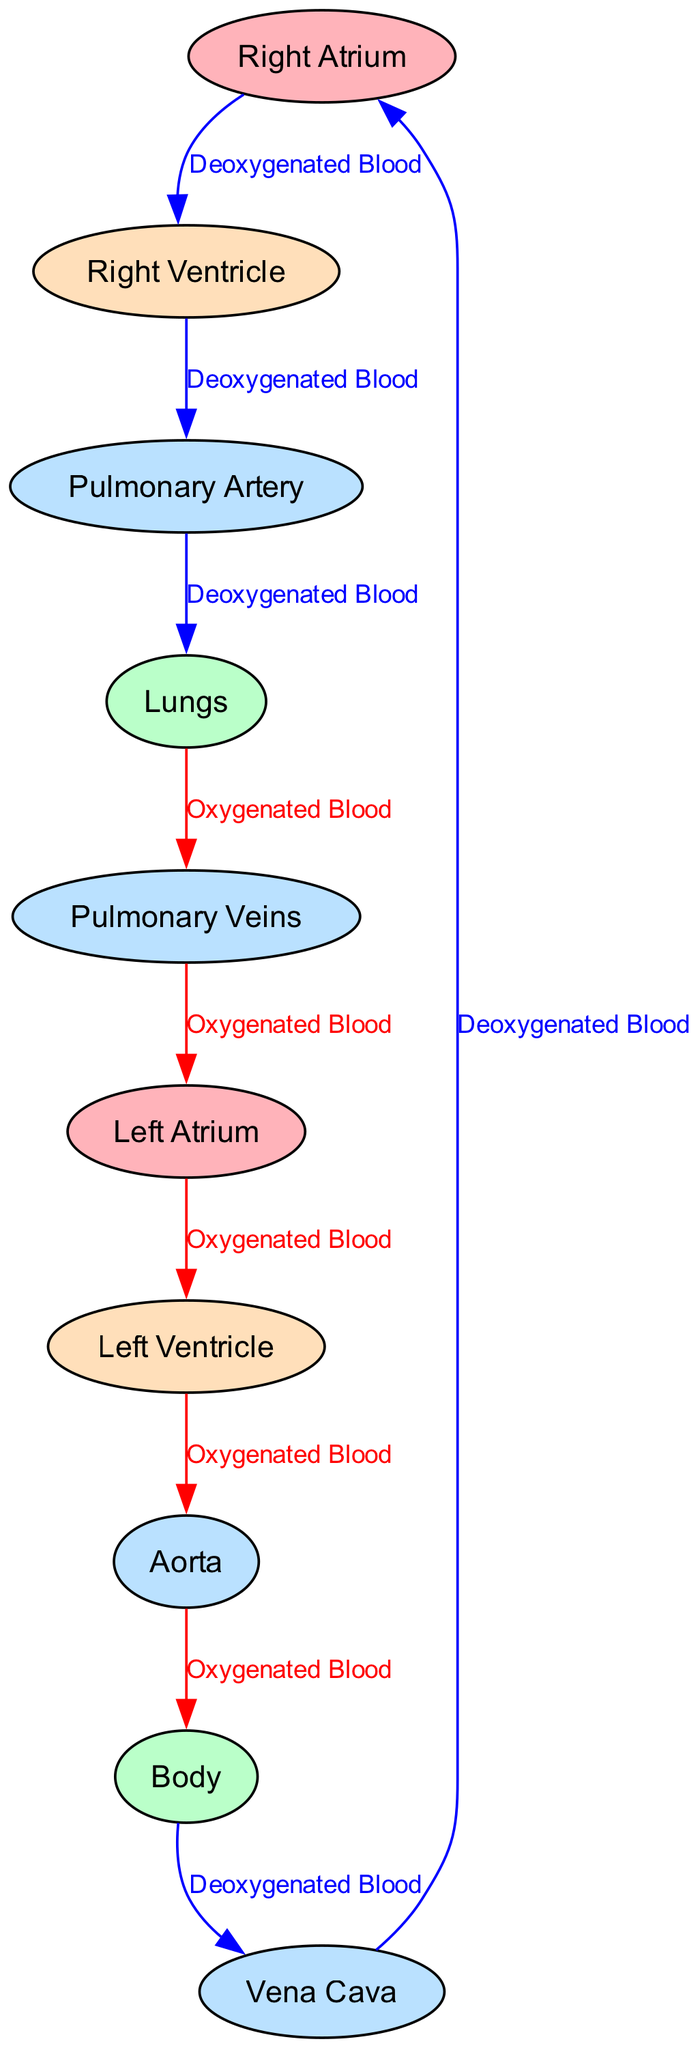What is the first chamber blood enters from the vena cava? The flow starts from the vena cava, which leads directly to the right atrium, as indicated by the directed edge in the diagram. Therefore, the first chamber is the right atrium.
Answer: Right Atrium How many major chambers are there in the heart? The diagram shows four major chambers: right atrium, right ventricle, left atrium, and left ventricle. By counting these nodes, we find there are four chambers in total.
Answer: 4 What type of blood flows from the left ventricle to the aorta? The edge labeled "Oxygenated Blood" indicates that blood leaving the left ventricle and heading to the aorta is oxygenated. Thus, the answer reflects the type of blood being transported.
Answer: Oxygenated Blood Which node receives deoxygenated blood just before reaching the lungs? Following the flow of deoxygenated blood from the right ventricle through the pulmonary artery, it leads to the lungs. Therefore, the lungs receive the deoxygenated blood just before it gets oxygenated.
Answer: Lungs What color represents the veins in this diagram? Based on the color coding explained in the diagram description, the nodes representing vessels, including veins, are colored light blue. Thus, the answer is directly related to the visual representation of veins.
Answer: Light Blue What is the last destination for oxygenated blood in this circulatory diagram? The flow path indicates that oxygenated blood travels from the aorta to the body, making the body the final destination before returning to the heart.
Answer: Body How many edges represent the flow of deoxygenated blood? By reviewing the connections in the diagram, there are five edges labeled with "Deoxygenated Blood" that represent its flow through the different nodes. Counting these will provide the answer.
Answer: 5 Which node connects the left atrium and left ventricle? The connection between the left atrium and left ventricle is defined by the directed edge labeled "Oxygenated Blood," thus showing the direct link between these two heart chambers.
Answer: Left Ventricle What is the link between the body and the vena cava? The directed edge shows that deoxygenated blood flows from the body back to the vena cava, closing the loop of circulation displayed in the diagram.
Answer: Deoxygenated Blood 